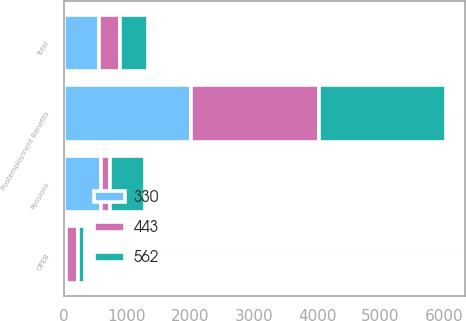Convert chart to OTSL. <chart><loc_0><loc_0><loc_500><loc_500><stacked_bar_chart><ecel><fcel>Postemployment Benefits<fcel>Pensions<fcel>OPEB<fcel>Total<nl><fcel>443<fcel>2013<fcel>134<fcel>196<fcel>330<nl><fcel>330<fcel>2012<fcel>596<fcel>34<fcel>562<nl><fcel>562<fcel>2011<fcel>555<fcel>112<fcel>443<nl></chart> 